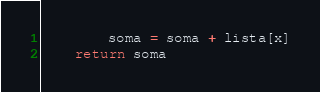<code> <loc_0><loc_0><loc_500><loc_500><_Python_>        soma = soma + lista[x]
    return soma
</code> 